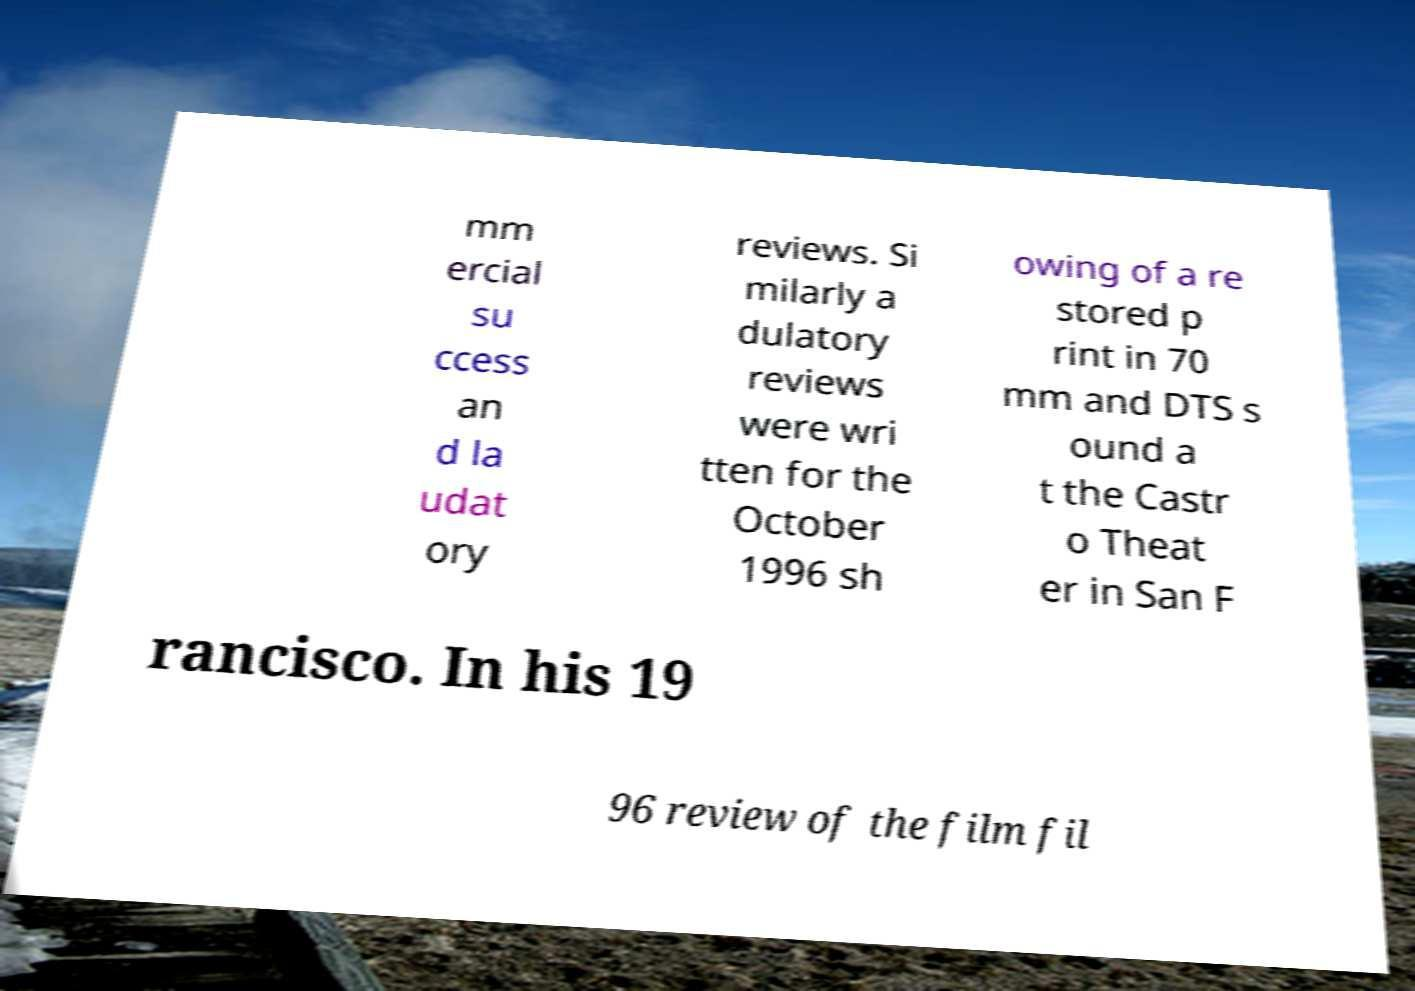For documentation purposes, I need the text within this image transcribed. Could you provide that? mm ercial su ccess an d la udat ory reviews. Si milarly a dulatory reviews were wri tten for the October 1996 sh owing of a re stored p rint in 70 mm and DTS s ound a t the Castr o Theat er in San F rancisco. In his 19 96 review of the film fil 